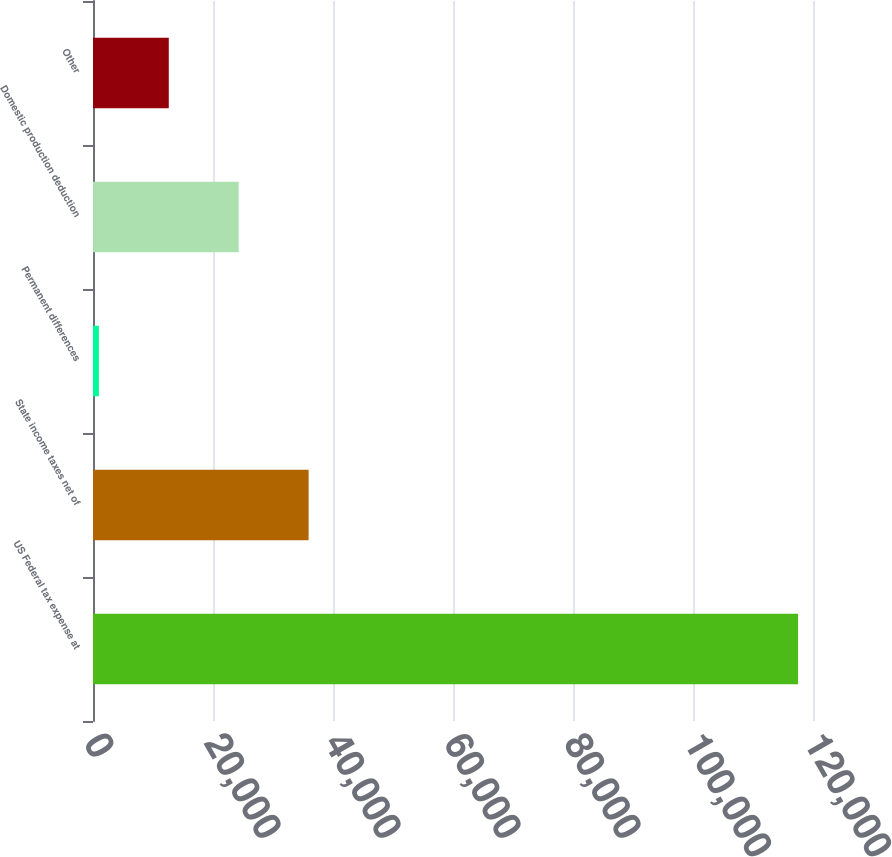<chart> <loc_0><loc_0><loc_500><loc_500><bar_chart><fcel>US Federal tax expense at<fcel>State income taxes net of<fcel>Permanent differences<fcel>Domestic production deduction<fcel>Other<nl><fcel>117510<fcel>35936.9<fcel>977<fcel>24283.6<fcel>12630.3<nl></chart> 